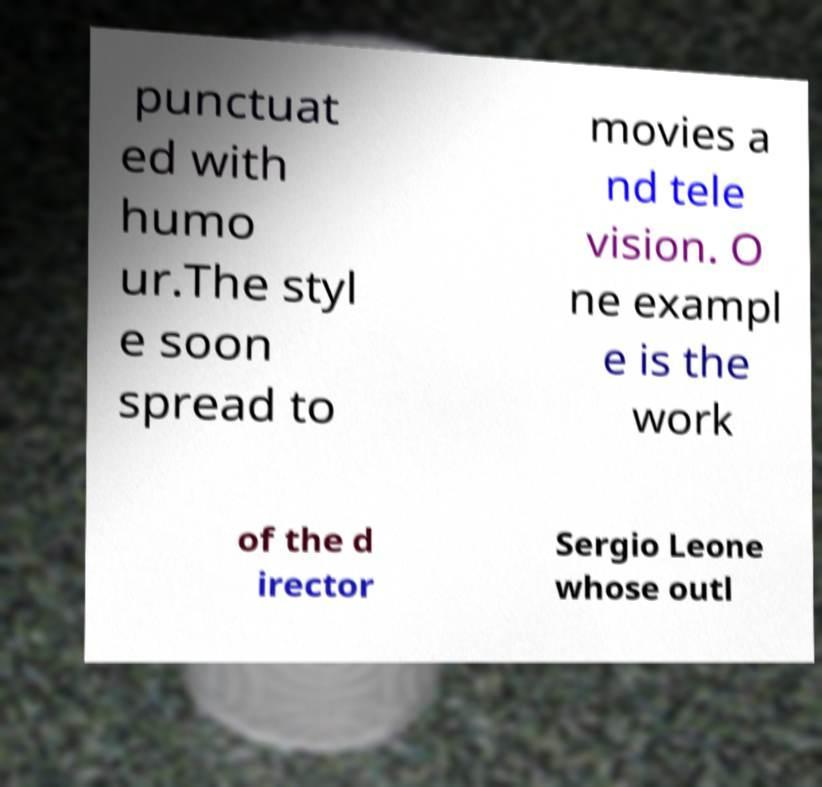Can you read and provide the text displayed in the image?This photo seems to have some interesting text. Can you extract and type it out for me? punctuat ed with humo ur.The styl e soon spread to movies a nd tele vision. O ne exampl e is the work of the d irector Sergio Leone whose outl 